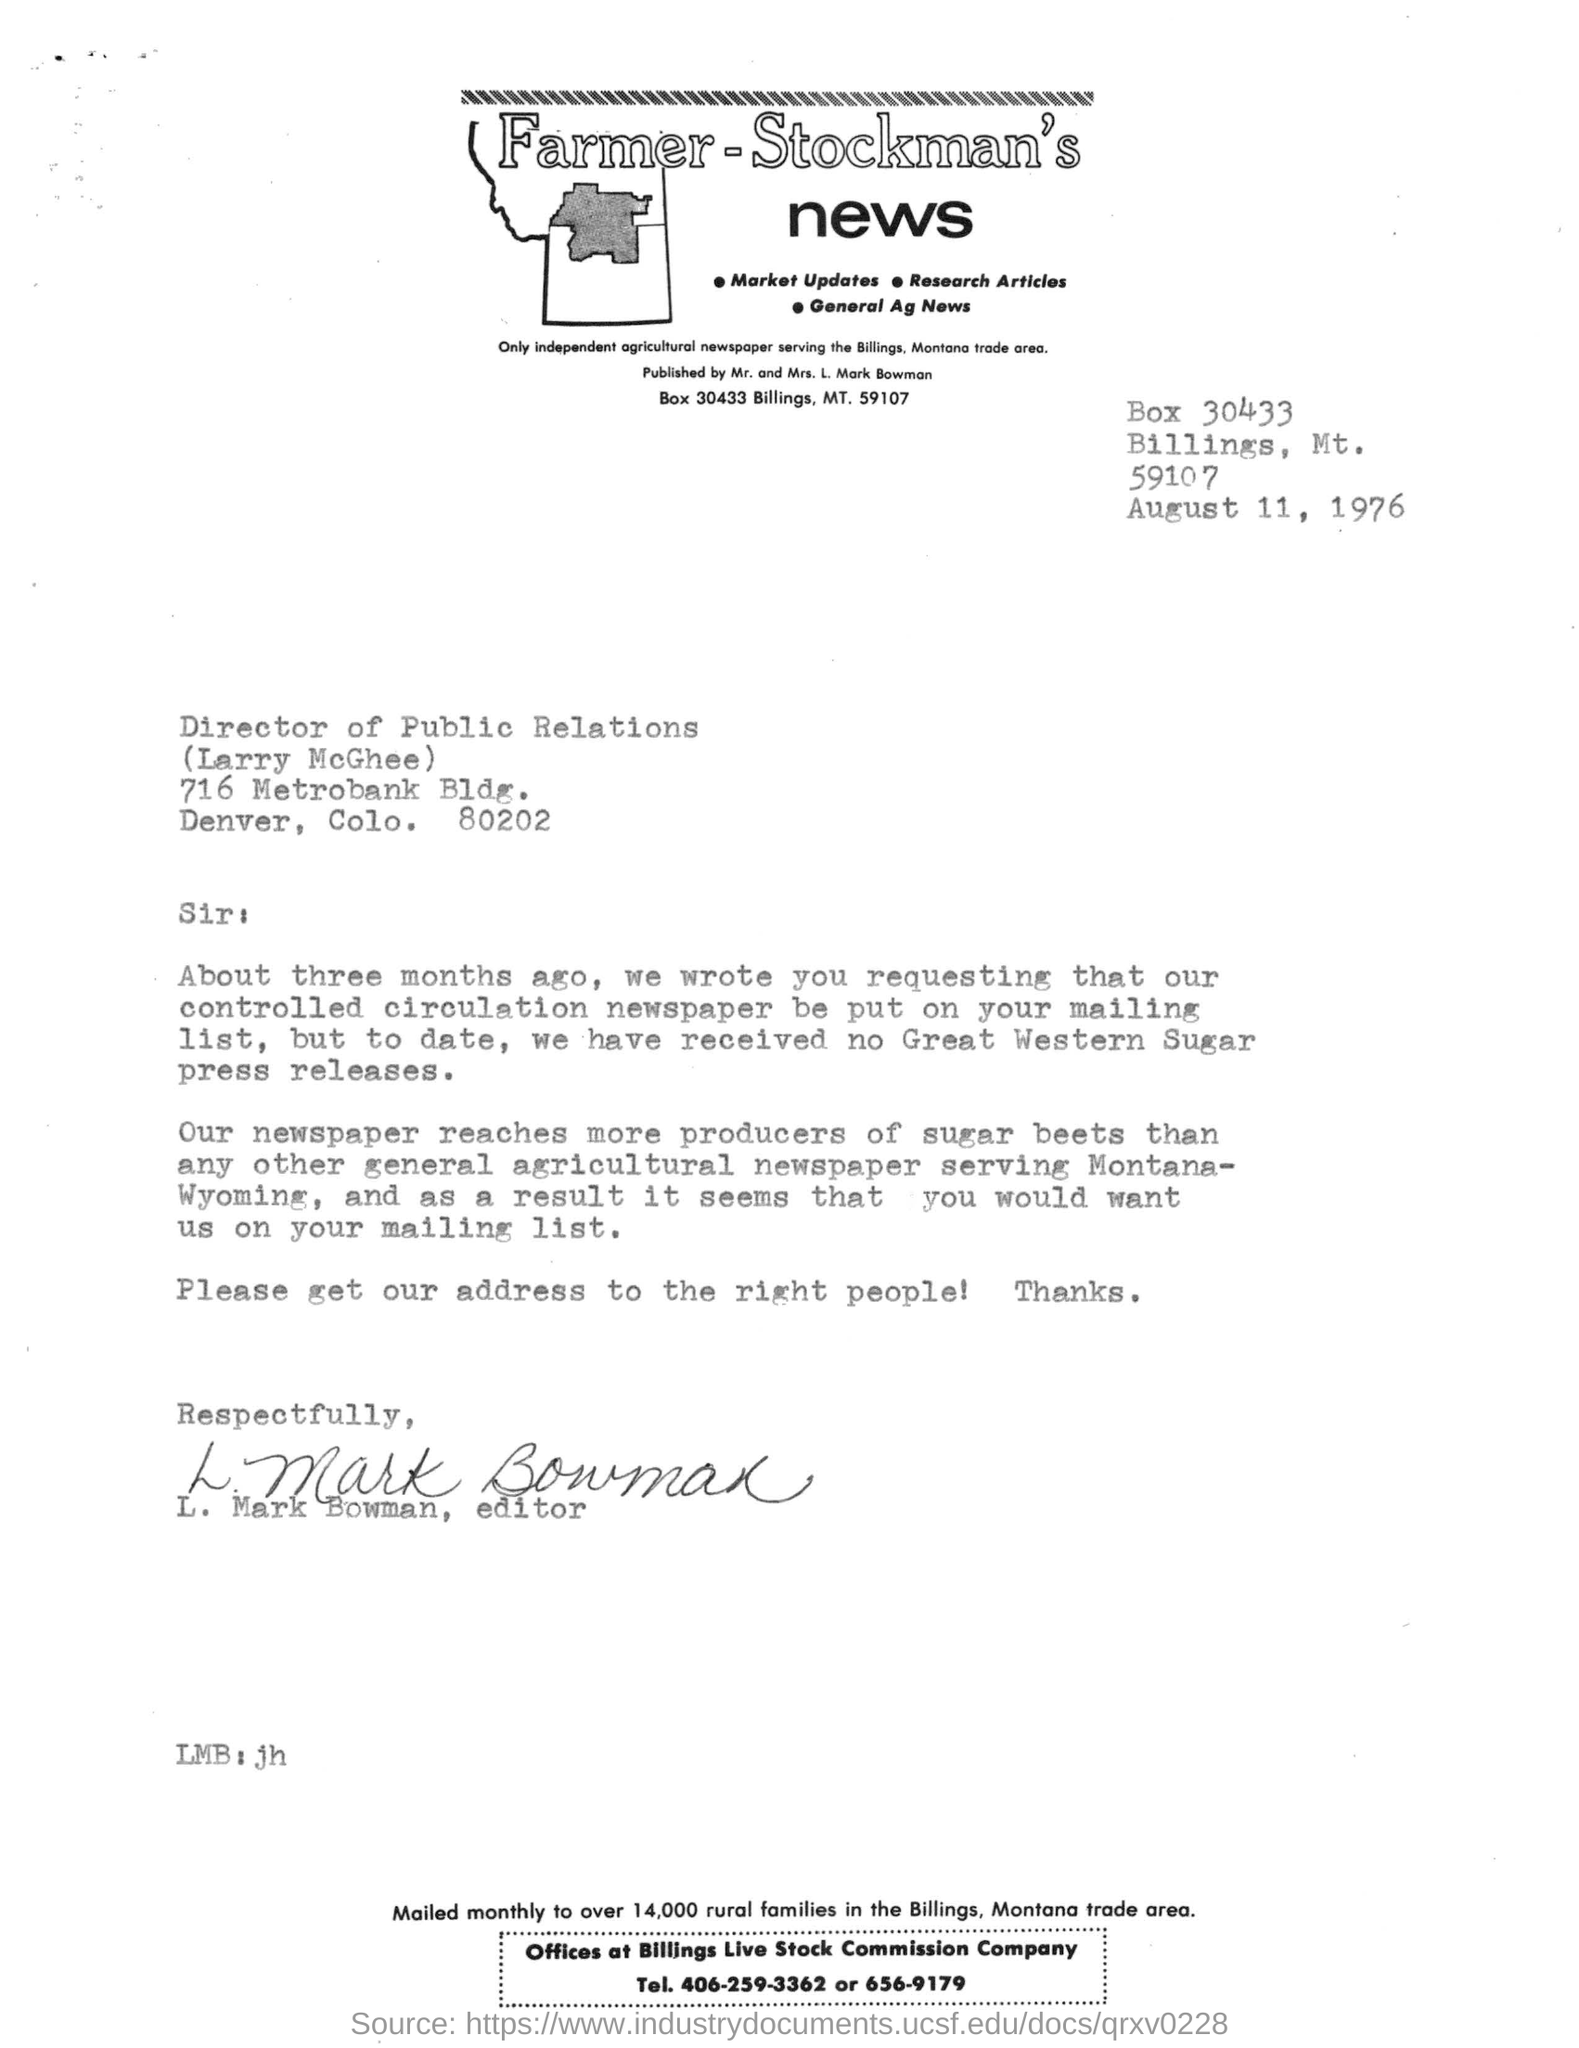Who is the publisher mentioned in the letter head?
Provide a succinct answer. L. Mark Bowman. Which date is mentioned in the letter?
Ensure brevity in your answer.  August 11, 1976. Who is the receiver of the letter?
Your response must be concise. Larry McGhee. Who is the sender of the letter?
Make the answer very short. L. Mark Bowman, editor. 